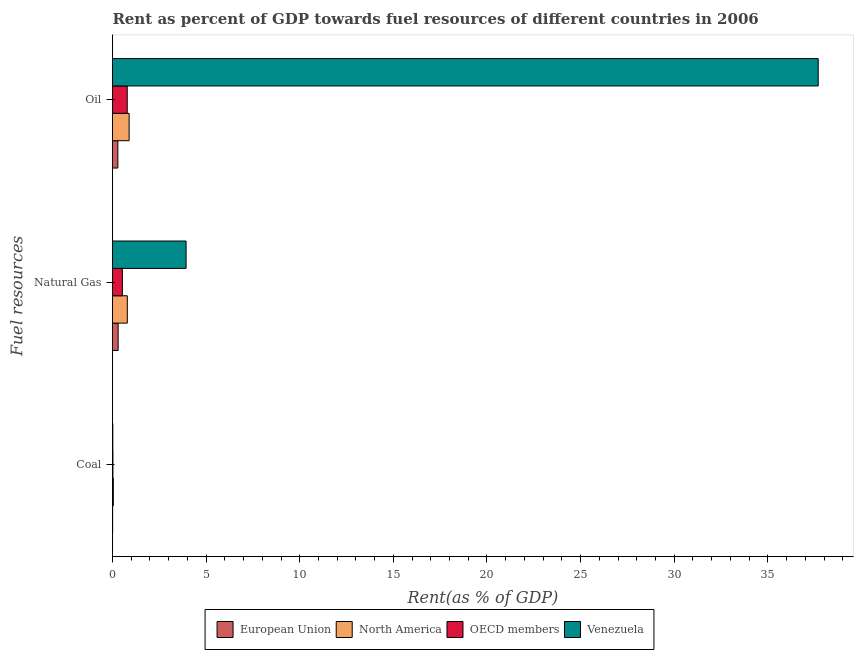How many different coloured bars are there?
Provide a succinct answer. 4. How many groups of bars are there?
Make the answer very short. 3. Are the number of bars per tick equal to the number of legend labels?
Provide a succinct answer. Yes. How many bars are there on the 3rd tick from the top?
Make the answer very short. 4. What is the label of the 2nd group of bars from the top?
Your answer should be very brief. Natural Gas. What is the rent towards oil in OECD members?
Your answer should be very brief. 0.79. Across all countries, what is the maximum rent towards coal?
Ensure brevity in your answer.  0.04. Across all countries, what is the minimum rent towards oil?
Offer a terse response. 0.29. In which country was the rent towards oil maximum?
Make the answer very short. Venezuela. What is the total rent towards coal in the graph?
Keep it short and to the point. 0.09. What is the difference between the rent towards natural gas in OECD members and that in Venezuela?
Your response must be concise. -3.4. What is the difference between the rent towards natural gas in North America and the rent towards oil in OECD members?
Give a very brief answer. 0. What is the average rent towards oil per country?
Offer a terse response. 9.91. What is the difference between the rent towards natural gas and rent towards coal in OECD members?
Your response must be concise. 0.5. What is the ratio of the rent towards oil in OECD members to that in Venezuela?
Offer a very short reply. 0.02. Is the difference between the rent towards coal in European Union and North America greater than the difference between the rent towards oil in European Union and North America?
Make the answer very short. Yes. What is the difference between the highest and the second highest rent towards natural gas?
Your answer should be very brief. 3.14. What is the difference between the highest and the lowest rent towards oil?
Your answer should be compact. 37.4. What does the 4th bar from the top in Coal represents?
Your answer should be very brief. European Union. Is it the case that in every country, the sum of the rent towards coal and rent towards natural gas is greater than the rent towards oil?
Your answer should be compact. No. Are all the bars in the graph horizontal?
Give a very brief answer. Yes. How many countries are there in the graph?
Provide a short and direct response. 4. Are the values on the major ticks of X-axis written in scientific E-notation?
Offer a very short reply. No. Does the graph contain grids?
Your response must be concise. No. What is the title of the graph?
Give a very brief answer. Rent as percent of GDP towards fuel resources of different countries in 2006. What is the label or title of the X-axis?
Give a very brief answer. Rent(as % of GDP). What is the label or title of the Y-axis?
Your answer should be compact. Fuel resources. What is the Rent(as % of GDP) of European Union in Coal?
Keep it short and to the point. 0.01. What is the Rent(as % of GDP) of North America in Coal?
Provide a short and direct response. 0.04. What is the Rent(as % of GDP) of OECD members in Coal?
Make the answer very short. 0.02. What is the Rent(as % of GDP) in Venezuela in Coal?
Your answer should be very brief. 0.02. What is the Rent(as % of GDP) in European Union in Natural Gas?
Your answer should be very brief. 0.3. What is the Rent(as % of GDP) in North America in Natural Gas?
Make the answer very short. 0.79. What is the Rent(as % of GDP) of OECD members in Natural Gas?
Make the answer very short. 0.53. What is the Rent(as % of GDP) in Venezuela in Natural Gas?
Keep it short and to the point. 3.93. What is the Rent(as % of GDP) in European Union in Oil?
Keep it short and to the point. 0.29. What is the Rent(as % of GDP) in North America in Oil?
Keep it short and to the point. 0.89. What is the Rent(as % of GDP) in OECD members in Oil?
Give a very brief answer. 0.79. What is the Rent(as % of GDP) of Venezuela in Oil?
Offer a terse response. 37.69. Across all Fuel resources, what is the maximum Rent(as % of GDP) of European Union?
Provide a short and direct response. 0.3. Across all Fuel resources, what is the maximum Rent(as % of GDP) of North America?
Your response must be concise. 0.89. Across all Fuel resources, what is the maximum Rent(as % of GDP) in OECD members?
Your answer should be very brief. 0.79. Across all Fuel resources, what is the maximum Rent(as % of GDP) of Venezuela?
Ensure brevity in your answer.  37.69. Across all Fuel resources, what is the minimum Rent(as % of GDP) of European Union?
Provide a short and direct response. 0.01. Across all Fuel resources, what is the minimum Rent(as % of GDP) of North America?
Offer a terse response. 0.04. Across all Fuel resources, what is the minimum Rent(as % of GDP) of OECD members?
Offer a terse response. 0.02. Across all Fuel resources, what is the minimum Rent(as % of GDP) in Venezuela?
Provide a short and direct response. 0.02. What is the total Rent(as % of GDP) in European Union in the graph?
Ensure brevity in your answer.  0.59. What is the total Rent(as % of GDP) in North America in the graph?
Your response must be concise. 1.72. What is the total Rent(as % of GDP) in OECD members in the graph?
Offer a terse response. 1.34. What is the total Rent(as % of GDP) of Venezuela in the graph?
Give a very brief answer. 41.64. What is the difference between the Rent(as % of GDP) in European Union in Coal and that in Natural Gas?
Give a very brief answer. -0.29. What is the difference between the Rent(as % of GDP) of North America in Coal and that in Natural Gas?
Your response must be concise. -0.75. What is the difference between the Rent(as % of GDP) of OECD members in Coal and that in Natural Gas?
Offer a very short reply. -0.5. What is the difference between the Rent(as % of GDP) in Venezuela in Coal and that in Natural Gas?
Keep it short and to the point. -3.91. What is the difference between the Rent(as % of GDP) in European Union in Coal and that in Oil?
Your response must be concise. -0.28. What is the difference between the Rent(as % of GDP) in North America in Coal and that in Oil?
Ensure brevity in your answer.  -0.84. What is the difference between the Rent(as % of GDP) in OECD members in Coal and that in Oil?
Provide a short and direct response. -0.76. What is the difference between the Rent(as % of GDP) in Venezuela in Coal and that in Oil?
Offer a very short reply. -37.67. What is the difference between the Rent(as % of GDP) of European Union in Natural Gas and that in Oil?
Ensure brevity in your answer.  0.02. What is the difference between the Rent(as % of GDP) of North America in Natural Gas and that in Oil?
Ensure brevity in your answer.  -0.1. What is the difference between the Rent(as % of GDP) of OECD members in Natural Gas and that in Oil?
Make the answer very short. -0.26. What is the difference between the Rent(as % of GDP) of Venezuela in Natural Gas and that in Oil?
Offer a terse response. -33.76. What is the difference between the Rent(as % of GDP) in European Union in Coal and the Rent(as % of GDP) in North America in Natural Gas?
Ensure brevity in your answer.  -0.78. What is the difference between the Rent(as % of GDP) of European Union in Coal and the Rent(as % of GDP) of OECD members in Natural Gas?
Keep it short and to the point. -0.52. What is the difference between the Rent(as % of GDP) in European Union in Coal and the Rent(as % of GDP) in Venezuela in Natural Gas?
Make the answer very short. -3.92. What is the difference between the Rent(as % of GDP) in North America in Coal and the Rent(as % of GDP) in OECD members in Natural Gas?
Keep it short and to the point. -0.48. What is the difference between the Rent(as % of GDP) of North America in Coal and the Rent(as % of GDP) of Venezuela in Natural Gas?
Provide a succinct answer. -3.89. What is the difference between the Rent(as % of GDP) in OECD members in Coal and the Rent(as % of GDP) in Venezuela in Natural Gas?
Offer a very short reply. -3.91. What is the difference between the Rent(as % of GDP) in European Union in Coal and the Rent(as % of GDP) in North America in Oil?
Your answer should be very brief. -0.88. What is the difference between the Rent(as % of GDP) of European Union in Coal and the Rent(as % of GDP) of OECD members in Oil?
Your answer should be very brief. -0.78. What is the difference between the Rent(as % of GDP) in European Union in Coal and the Rent(as % of GDP) in Venezuela in Oil?
Make the answer very short. -37.68. What is the difference between the Rent(as % of GDP) in North America in Coal and the Rent(as % of GDP) in OECD members in Oil?
Give a very brief answer. -0.74. What is the difference between the Rent(as % of GDP) of North America in Coal and the Rent(as % of GDP) of Venezuela in Oil?
Your response must be concise. -37.65. What is the difference between the Rent(as % of GDP) of OECD members in Coal and the Rent(as % of GDP) of Venezuela in Oil?
Provide a succinct answer. -37.67. What is the difference between the Rent(as % of GDP) in European Union in Natural Gas and the Rent(as % of GDP) in North America in Oil?
Ensure brevity in your answer.  -0.59. What is the difference between the Rent(as % of GDP) of European Union in Natural Gas and the Rent(as % of GDP) of OECD members in Oil?
Ensure brevity in your answer.  -0.49. What is the difference between the Rent(as % of GDP) in European Union in Natural Gas and the Rent(as % of GDP) in Venezuela in Oil?
Provide a succinct answer. -37.39. What is the difference between the Rent(as % of GDP) in North America in Natural Gas and the Rent(as % of GDP) in OECD members in Oil?
Provide a short and direct response. 0. What is the difference between the Rent(as % of GDP) in North America in Natural Gas and the Rent(as % of GDP) in Venezuela in Oil?
Offer a very short reply. -36.9. What is the difference between the Rent(as % of GDP) of OECD members in Natural Gas and the Rent(as % of GDP) of Venezuela in Oil?
Give a very brief answer. -37.16. What is the average Rent(as % of GDP) in European Union per Fuel resources?
Your answer should be compact. 0.2. What is the average Rent(as % of GDP) in North America per Fuel resources?
Give a very brief answer. 0.57. What is the average Rent(as % of GDP) in OECD members per Fuel resources?
Your answer should be compact. 0.45. What is the average Rent(as % of GDP) in Venezuela per Fuel resources?
Provide a short and direct response. 13.88. What is the difference between the Rent(as % of GDP) of European Union and Rent(as % of GDP) of North America in Coal?
Ensure brevity in your answer.  -0.04. What is the difference between the Rent(as % of GDP) of European Union and Rent(as % of GDP) of OECD members in Coal?
Your response must be concise. -0.02. What is the difference between the Rent(as % of GDP) in European Union and Rent(as % of GDP) in Venezuela in Coal?
Your answer should be very brief. -0.01. What is the difference between the Rent(as % of GDP) of North America and Rent(as % of GDP) of OECD members in Coal?
Keep it short and to the point. 0.02. What is the difference between the Rent(as % of GDP) of North America and Rent(as % of GDP) of Venezuela in Coal?
Your answer should be compact. 0.03. What is the difference between the Rent(as % of GDP) of OECD members and Rent(as % of GDP) of Venezuela in Coal?
Offer a terse response. 0.01. What is the difference between the Rent(as % of GDP) in European Union and Rent(as % of GDP) in North America in Natural Gas?
Offer a terse response. -0.49. What is the difference between the Rent(as % of GDP) of European Union and Rent(as % of GDP) of OECD members in Natural Gas?
Make the answer very short. -0.23. What is the difference between the Rent(as % of GDP) in European Union and Rent(as % of GDP) in Venezuela in Natural Gas?
Provide a short and direct response. -3.63. What is the difference between the Rent(as % of GDP) in North America and Rent(as % of GDP) in OECD members in Natural Gas?
Give a very brief answer. 0.26. What is the difference between the Rent(as % of GDP) of North America and Rent(as % of GDP) of Venezuela in Natural Gas?
Make the answer very short. -3.14. What is the difference between the Rent(as % of GDP) in OECD members and Rent(as % of GDP) in Venezuela in Natural Gas?
Make the answer very short. -3.4. What is the difference between the Rent(as % of GDP) in European Union and Rent(as % of GDP) in North America in Oil?
Provide a succinct answer. -0.6. What is the difference between the Rent(as % of GDP) in European Union and Rent(as % of GDP) in OECD members in Oil?
Make the answer very short. -0.5. What is the difference between the Rent(as % of GDP) in European Union and Rent(as % of GDP) in Venezuela in Oil?
Offer a very short reply. -37.4. What is the difference between the Rent(as % of GDP) of North America and Rent(as % of GDP) of OECD members in Oil?
Offer a very short reply. 0.1. What is the difference between the Rent(as % of GDP) of North America and Rent(as % of GDP) of Venezuela in Oil?
Provide a succinct answer. -36.8. What is the difference between the Rent(as % of GDP) in OECD members and Rent(as % of GDP) in Venezuela in Oil?
Provide a short and direct response. -36.9. What is the ratio of the Rent(as % of GDP) in European Union in Coal to that in Natural Gas?
Your answer should be very brief. 0.03. What is the ratio of the Rent(as % of GDP) in North America in Coal to that in Natural Gas?
Provide a short and direct response. 0.06. What is the ratio of the Rent(as % of GDP) in OECD members in Coal to that in Natural Gas?
Ensure brevity in your answer.  0.04. What is the ratio of the Rent(as % of GDP) in Venezuela in Coal to that in Natural Gas?
Offer a terse response. 0. What is the ratio of the Rent(as % of GDP) in European Union in Coal to that in Oil?
Make the answer very short. 0.03. What is the ratio of the Rent(as % of GDP) of North America in Coal to that in Oil?
Provide a short and direct response. 0.05. What is the ratio of the Rent(as % of GDP) in OECD members in Coal to that in Oil?
Your response must be concise. 0.03. What is the ratio of the Rent(as % of GDP) of European Union in Natural Gas to that in Oil?
Your answer should be very brief. 1.05. What is the ratio of the Rent(as % of GDP) in North America in Natural Gas to that in Oil?
Give a very brief answer. 0.89. What is the ratio of the Rent(as % of GDP) in OECD members in Natural Gas to that in Oil?
Provide a succinct answer. 0.67. What is the ratio of the Rent(as % of GDP) of Venezuela in Natural Gas to that in Oil?
Ensure brevity in your answer.  0.1. What is the difference between the highest and the second highest Rent(as % of GDP) in European Union?
Your answer should be compact. 0.02. What is the difference between the highest and the second highest Rent(as % of GDP) in North America?
Offer a terse response. 0.1. What is the difference between the highest and the second highest Rent(as % of GDP) in OECD members?
Offer a terse response. 0.26. What is the difference between the highest and the second highest Rent(as % of GDP) of Venezuela?
Your answer should be very brief. 33.76. What is the difference between the highest and the lowest Rent(as % of GDP) of European Union?
Your answer should be compact. 0.29. What is the difference between the highest and the lowest Rent(as % of GDP) of North America?
Keep it short and to the point. 0.84. What is the difference between the highest and the lowest Rent(as % of GDP) in OECD members?
Provide a short and direct response. 0.76. What is the difference between the highest and the lowest Rent(as % of GDP) of Venezuela?
Ensure brevity in your answer.  37.67. 